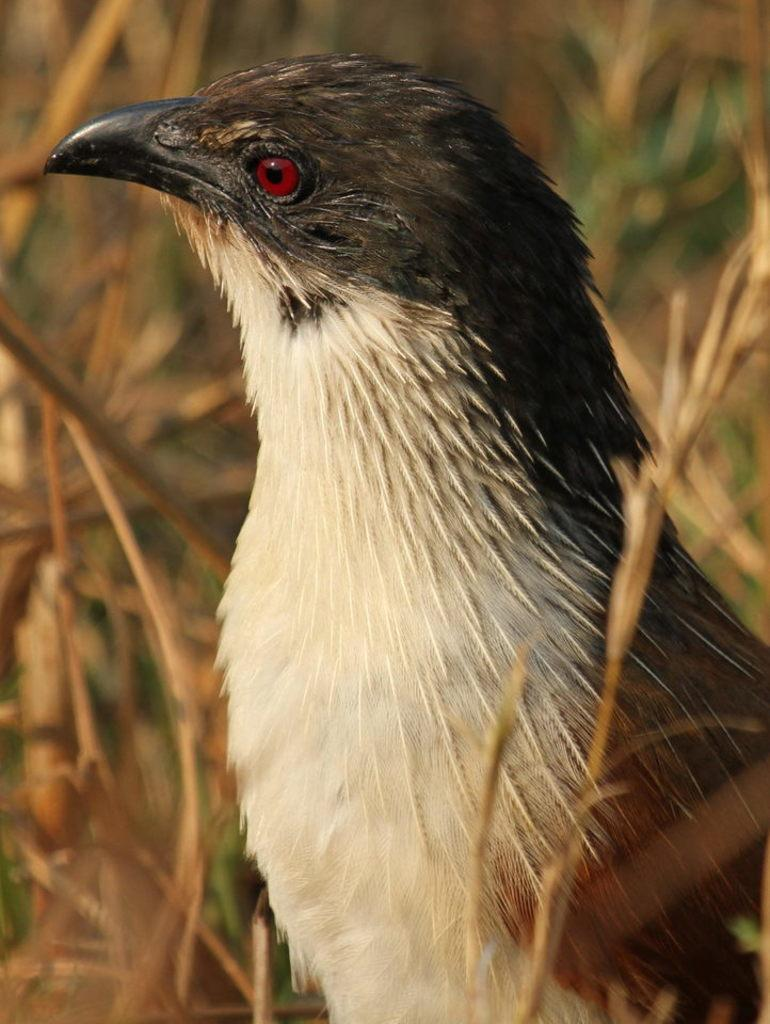What is the main subject in the center of the image? There is a bird in the center of the image. What type of environment can be seen in the background of the image? There is grass in the background of the image. What type of iron is visible in the image? There is no iron present in the image; it features a bird and grass. 